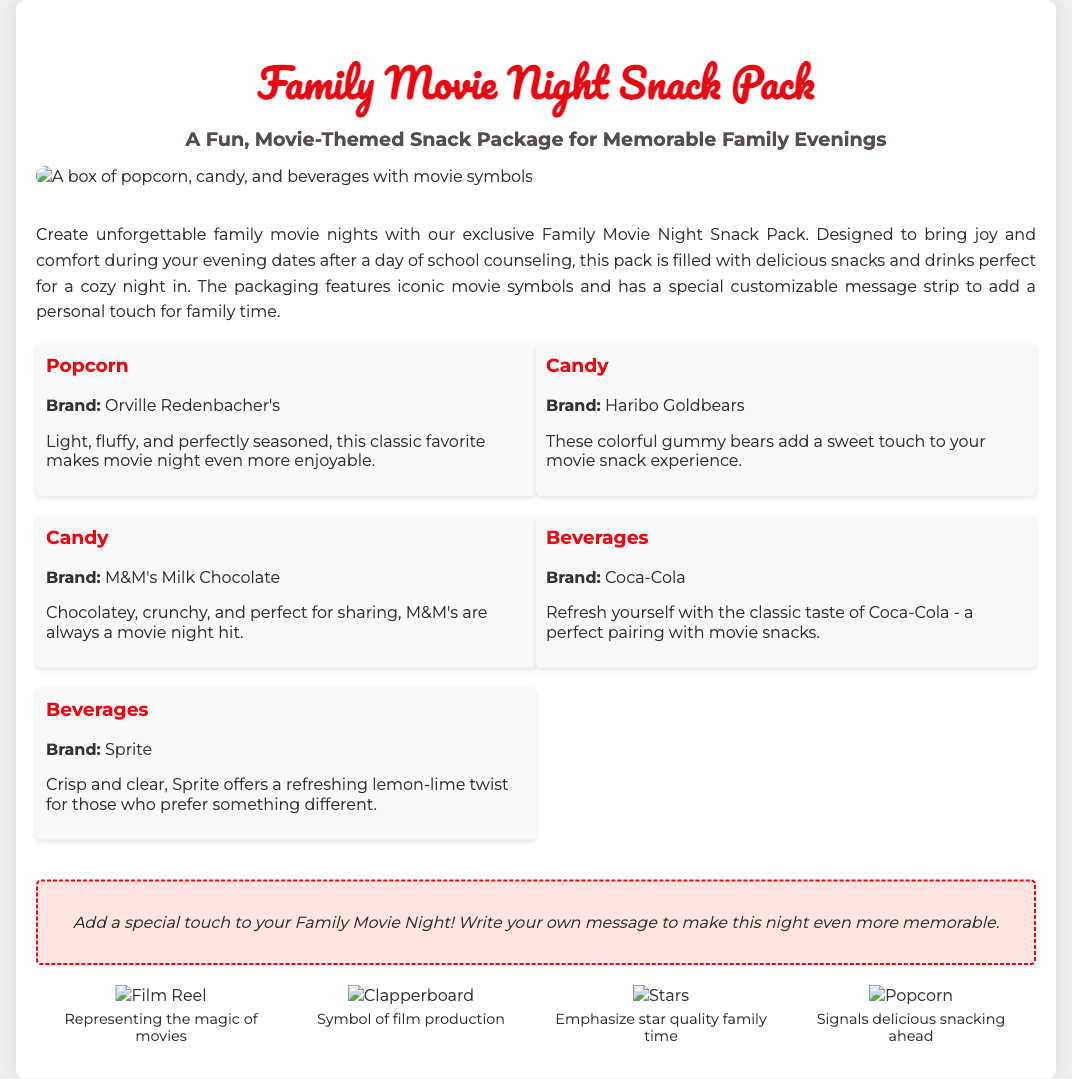what is the name of the snack pack? The title of the product is mentioned at the beginning of the document.
Answer: Family Movie Night Snack Pack what beverages are included in the pack? The document lists the beverages in the contents section, specifically mentioning brands.
Answer: Coca-Cola and Sprite what is a unique feature of the packaging? The document highlights a specific feature that adds a personal touch in the description area.
Answer: Customizable message strip which candy brand is mentioned first? The order of the candy brands is indicated under the contents section of the document.
Answer: Haribo Goldbears how many design elements are shown? The document presents a specific count of design elements in the design elements section.
Answer: Four what do the design elements represent? The document describes the meaning behind each design element in the design elements section.
Answer: Movie symbols what type of occasion is the snack pack designed for? The introduction of the document mentions the specific use case for the snack pack.
Answer: Family movie nights how should the customizable message strip be used? The document provides guidance on the purpose of this feature in the customizable message section.
Answer: Add a special touch to your Family Movie Night how is the popcorn described? The description for the popcorn is included in the contents section.
Answer: Light, fluffy, and perfectly seasoned 